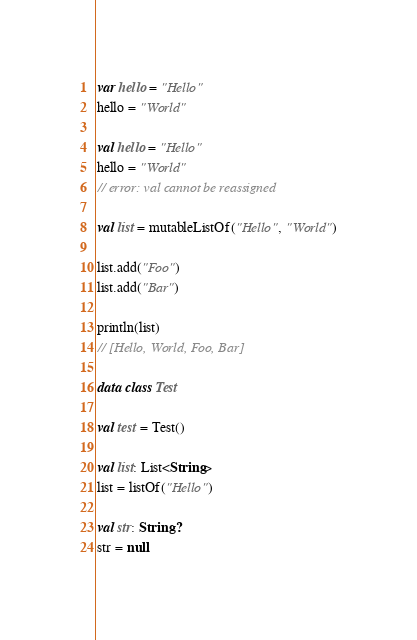<code> <loc_0><loc_0><loc_500><loc_500><_Kotlin_>var hello = "Hello"
hello = "World"

val hello = "Hello"
hello = "World"
// error: val cannot be reassigned

val list = mutableListOf("Hello", "World")

list.add("Foo")
list.add("Bar")

println(list)
// [Hello, World, Foo, Bar]

data class Test

val test = Test()

val list: List<String>
list = listOf("Hello")

val str: String?
str = null
</code> 